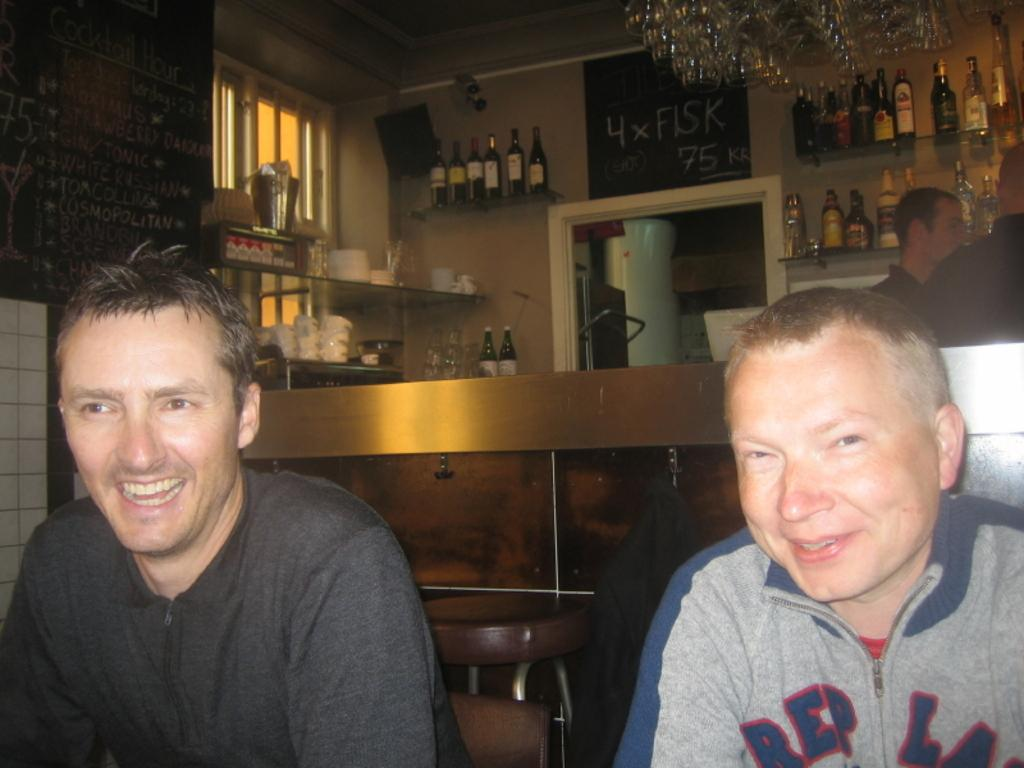How many people are present in the image? There are two men in the image. What can be seen in the background of the image? There is a mini bar in the background of the image. What items are present in the mini bar? There are wine bottles in the mini bar. What type of rod is being used by the representative in the image? There is no rod or representative present in the image. How many yams are visible on the table in the image? There are no yams present in the image. 